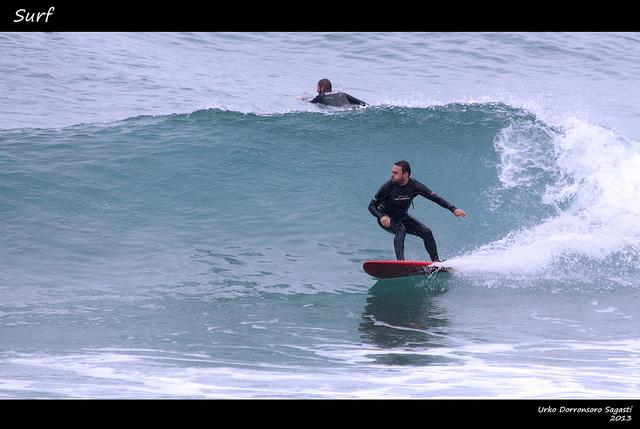Why does the man on the surf board crouch?

Choices:
A) stealth hiding
B) shark sighting
C) improved balance
D) he's falling improved balance 